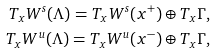<formula> <loc_0><loc_0><loc_500><loc_500>T _ { x } W ^ { s } ( \Lambda ) = T _ { x } W ^ { s } ( x ^ { + } ) \oplus T _ { x } \Gamma , \\ T _ { x } W ^ { u } ( \Lambda ) = T _ { x } W ^ { u } ( x ^ { - } ) \oplus T _ { x } \Gamma ,</formula> 